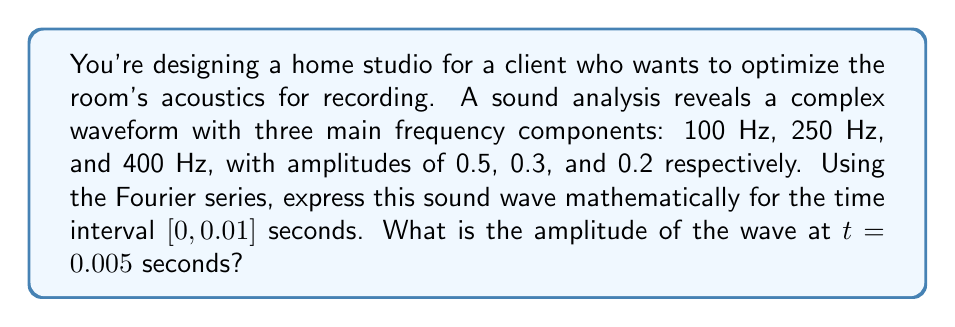Can you answer this question? To solve this problem, we'll use the Fourier series to represent the complex sound wave and then evaluate it at the given time.

1. The general form of a Fourier series for a periodic function is:

   $$f(t) = A_0 + \sum_{n=1}^{\infty} A_n \cos(2\pi n f_0 t) + B_n \sin(2\pi n f_0 t)$$

   Where $A_0$ is the DC component (which is 0 in this case), and $A_n$ and $B_n$ are the amplitudes of the cosine and sine terms respectively.

2. In our case, we have three frequency components, so we can simplify this to:

   $$f(t) = A_1 \cos(2\pi f_1 t) + A_2 \cos(2\pi f_2 t) + A_3 \cos(2\pi f_3 t)$$

   Where:
   $A_1 = 0.5$, $f_1 = 100$ Hz
   $A_2 = 0.3$, $f_2 = 250$ Hz
   $A_3 = 0.2$, $f_3 = 400$ Hz

3. Substituting these values:

   $$f(t) = 0.5 \cos(200\pi t) + 0.3 \cos(500\pi t) + 0.2 \cos(800\pi t)$$

4. To find the amplitude at $t = 0.005$ seconds, we simply substitute this value of $t$ into our equation:

   $$f(0.005) = 0.5 \cos(200\pi \cdot 0.005) + 0.3 \cos(500\pi \cdot 0.005) + 0.2 \cos(800\pi \cdot 0.005)$$

5. Simplifying:

   $$f(0.005) = 0.5 \cos(\pi) + 0.3 \cos(2.5\pi) + 0.2 \cos(4\pi)$$

6. Calculating:

   $$f(0.005) = 0.5 \cdot (-1) + 0.3 \cdot 0 + 0.2 \cdot 1 = -0.3$$

Therefore, the amplitude of the wave at $t = 0.005$ seconds is -0.3.
Answer: $-0.3$ 